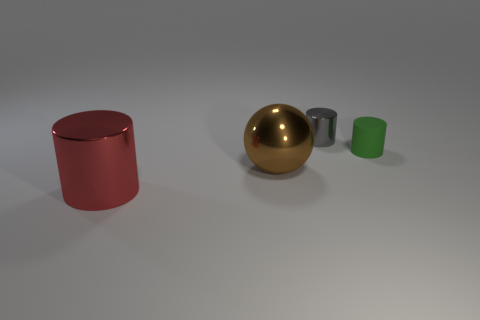What number of other gray objects have the same shape as the tiny gray metal thing?
Keep it short and to the point. 0. What is the shape of the green thing?
Keep it short and to the point. Cylinder. Are there the same number of large brown metal things on the right side of the green rubber cylinder and matte cylinders?
Ensure brevity in your answer.  No. Is there any other thing that is the same material as the big brown ball?
Your response must be concise. Yes. Are the tiny cylinder that is in front of the small gray metal cylinder and the large red cylinder made of the same material?
Give a very brief answer. No. Is the number of green matte objects that are in front of the small gray thing less than the number of big brown spheres?
Provide a short and direct response. No. How many matte things are either big brown spheres or tiny green things?
Your answer should be compact. 1. Do the tiny matte cylinder and the tiny shiny thing have the same color?
Make the answer very short. No. Is there anything else that is the same color as the small shiny thing?
Provide a succinct answer. No. Do the shiny object that is behind the brown ball and the big object that is behind the big red object have the same shape?
Offer a terse response. No. 